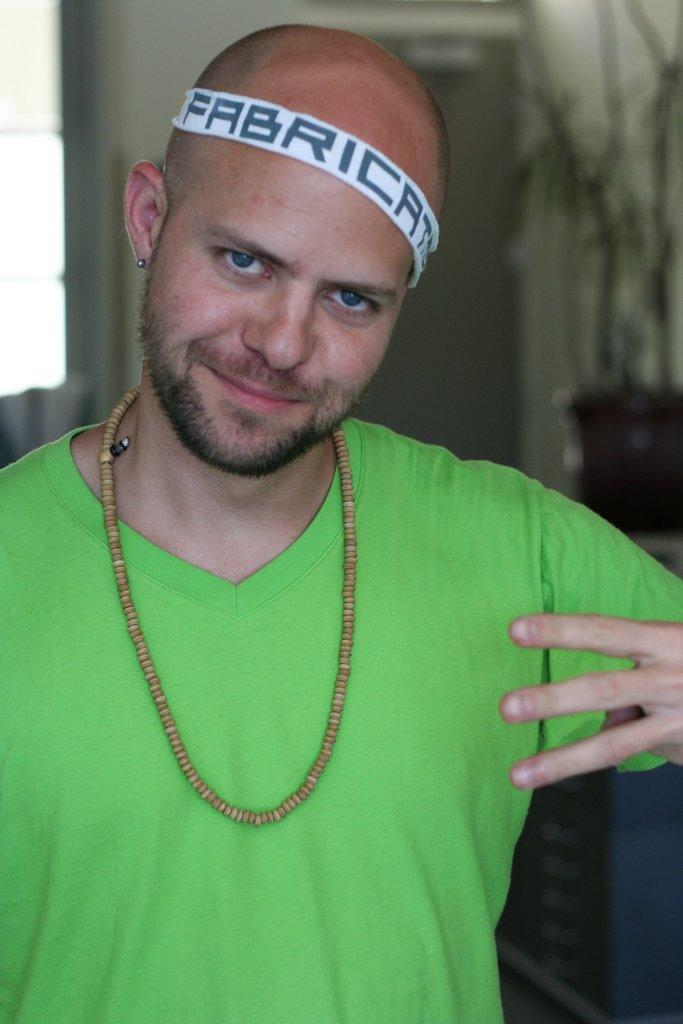Who is present in the image? There is a man in the image. What is the man wearing on his upper body? The man is wearing a green t-shirt. What accessory is the man wearing on his head? The man is wearing a headband. Can you describe the background of the image? The background of the image is blurry. What type of bomb is the man holding in the image? There is no bomb present in the image; the man is not holding any object. 